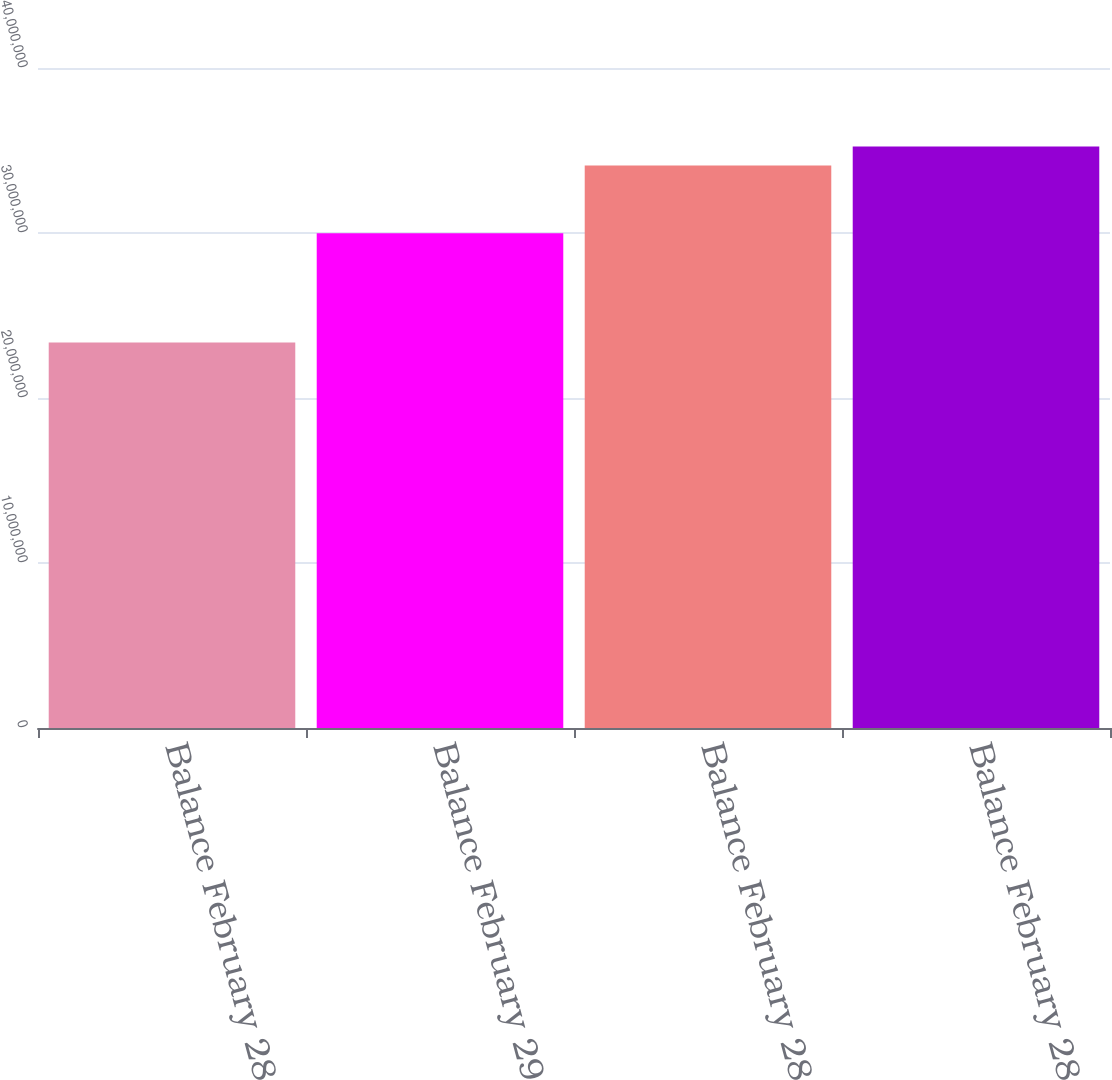<chart> <loc_0><loc_0><loc_500><loc_500><bar_chart><fcel>Balance February 28 2007<fcel>Balance February 29 2008<fcel>Balance February 28 2009<fcel>Balance February 28 2010<nl><fcel>2.33685e+07<fcel>2.99919e+07<fcel>3.4096e+07<fcel>3.52437e+07<nl></chart> 